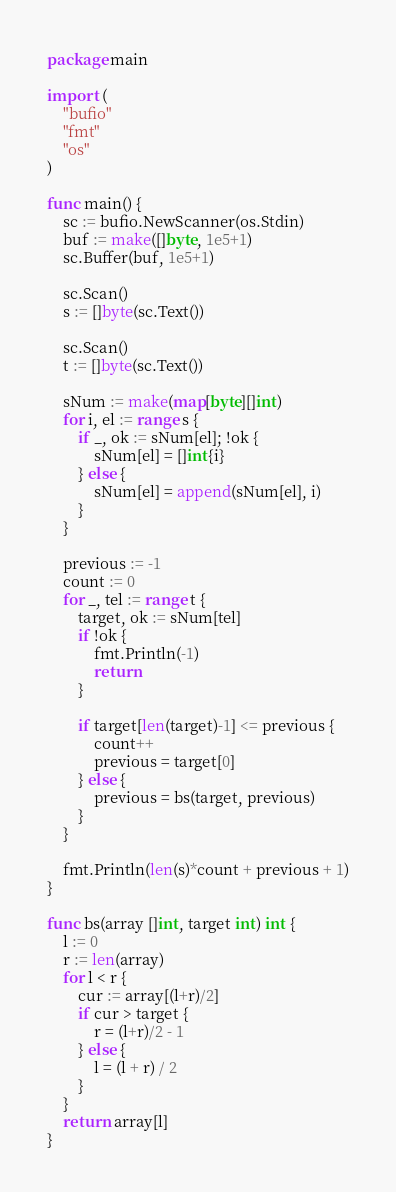<code> <loc_0><loc_0><loc_500><loc_500><_Go_>package main

import (
	"bufio"
	"fmt"
	"os"
)

func main() {
	sc := bufio.NewScanner(os.Stdin)
	buf := make([]byte, 1e5+1)
	sc.Buffer(buf, 1e5+1)

	sc.Scan()
	s := []byte(sc.Text())

	sc.Scan()
	t := []byte(sc.Text())

	sNum := make(map[byte][]int)
	for i, el := range s {
		if _, ok := sNum[el]; !ok {
			sNum[el] = []int{i}
		} else {
			sNum[el] = append(sNum[el], i)
		}
	}

	previous := -1
	count := 0
	for _, tel := range t {
		target, ok := sNum[tel]
		if !ok {
			fmt.Println(-1)
			return
		}

		if target[len(target)-1] <= previous {
			count++
			previous = target[0]
		} else {
			previous = bs(target, previous)
		}
	}

	fmt.Println(len(s)*count + previous + 1)
}

func bs(array []int, target int) int {
	l := 0
	r := len(array)
	for l < r {
		cur := array[(l+r)/2]
		if cur > target {
			r = (l+r)/2 - 1
		} else {
			l = (l + r) / 2
		}
	}
	return array[l]
}
</code> 